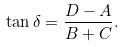Convert formula to latex. <formula><loc_0><loc_0><loc_500><loc_500>\tan \delta = \frac { D - A } { B + C } .</formula> 